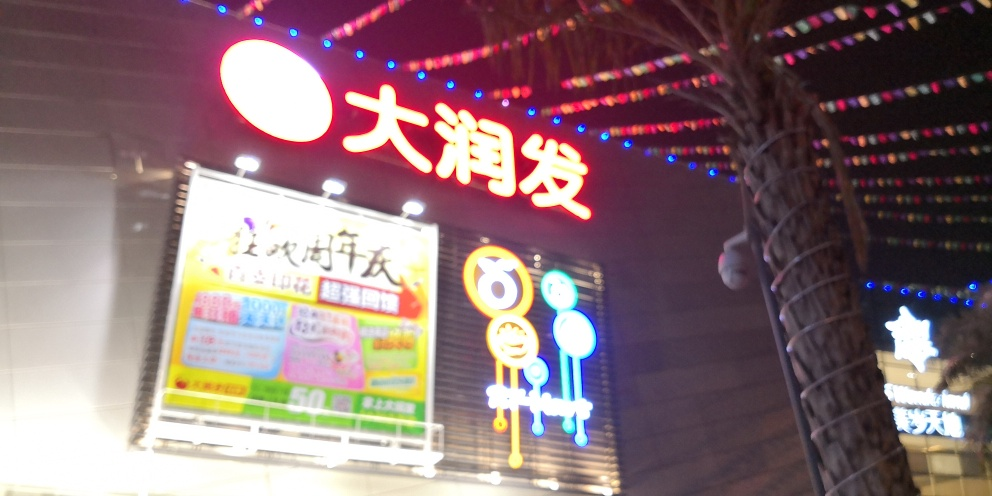What kind of establishments are advertised in this image? The image shows signs that appear to advertise various businesses, possibly including dining or entertainment venues. The presence of multicolored lights and what looks like advertisements suggests this is a commercial area. 